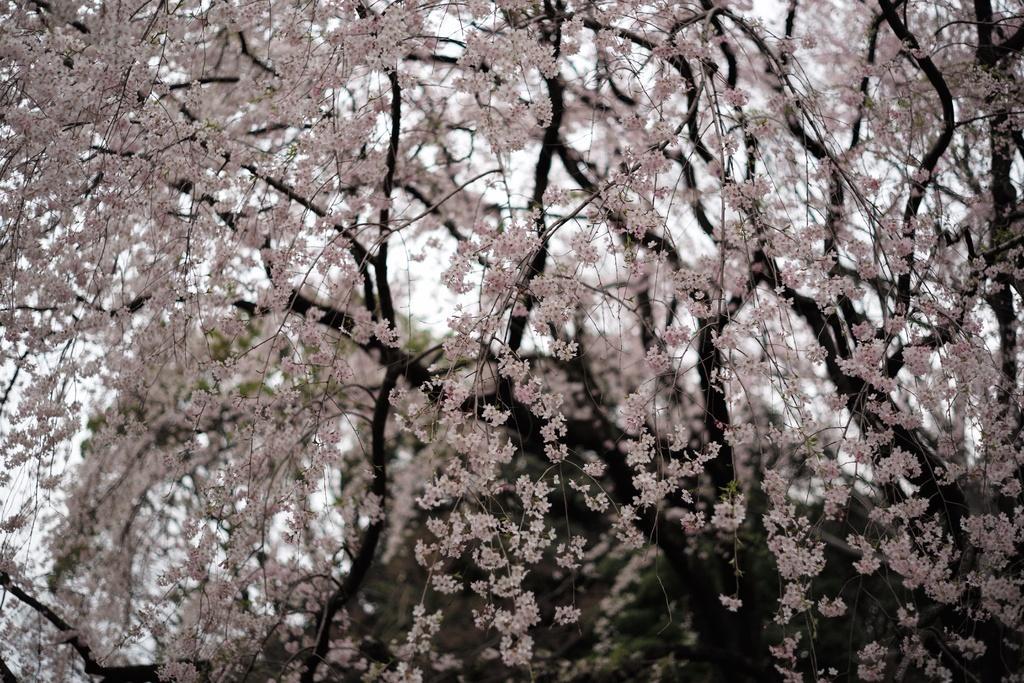Describe this image in one or two sentences. In this image I can see many trees. In the background I can see the sky. 